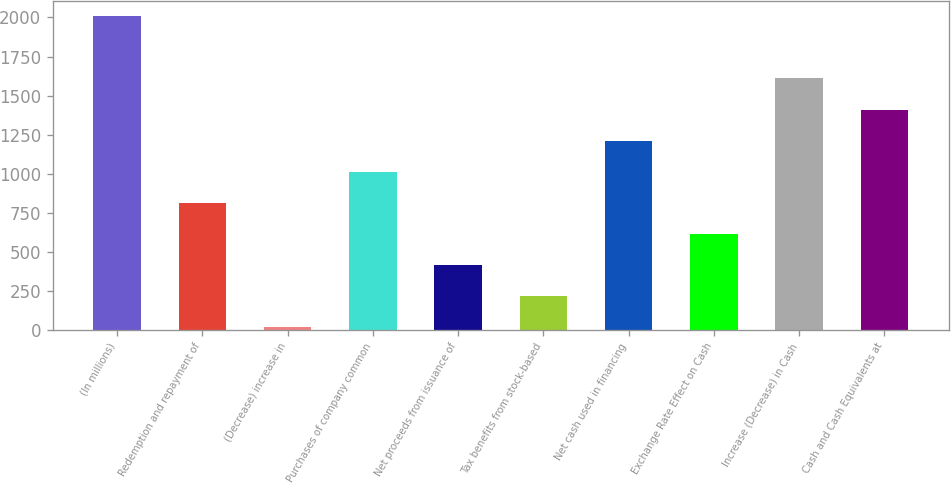Convert chart. <chart><loc_0><loc_0><loc_500><loc_500><bar_chart><fcel>(In millions)<fcel>Redemption and repayment of<fcel>(Decrease) increase in<fcel>Purchases of company common<fcel>Net proceeds from issuance of<fcel>Tax benefits from stock-based<fcel>Net cash used in financing<fcel>Exchange Rate Effect on Cash<fcel>Increase (Decrease) in Cash<fcel>Cash and Cash Equivalents at<nl><fcel>2008<fcel>812.44<fcel>15.4<fcel>1011.7<fcel>413.92<fcel>214.66<fcel>1210.96<fcel>613.18<fcel>1609.48<fcel>1410.22<nl></chart> 